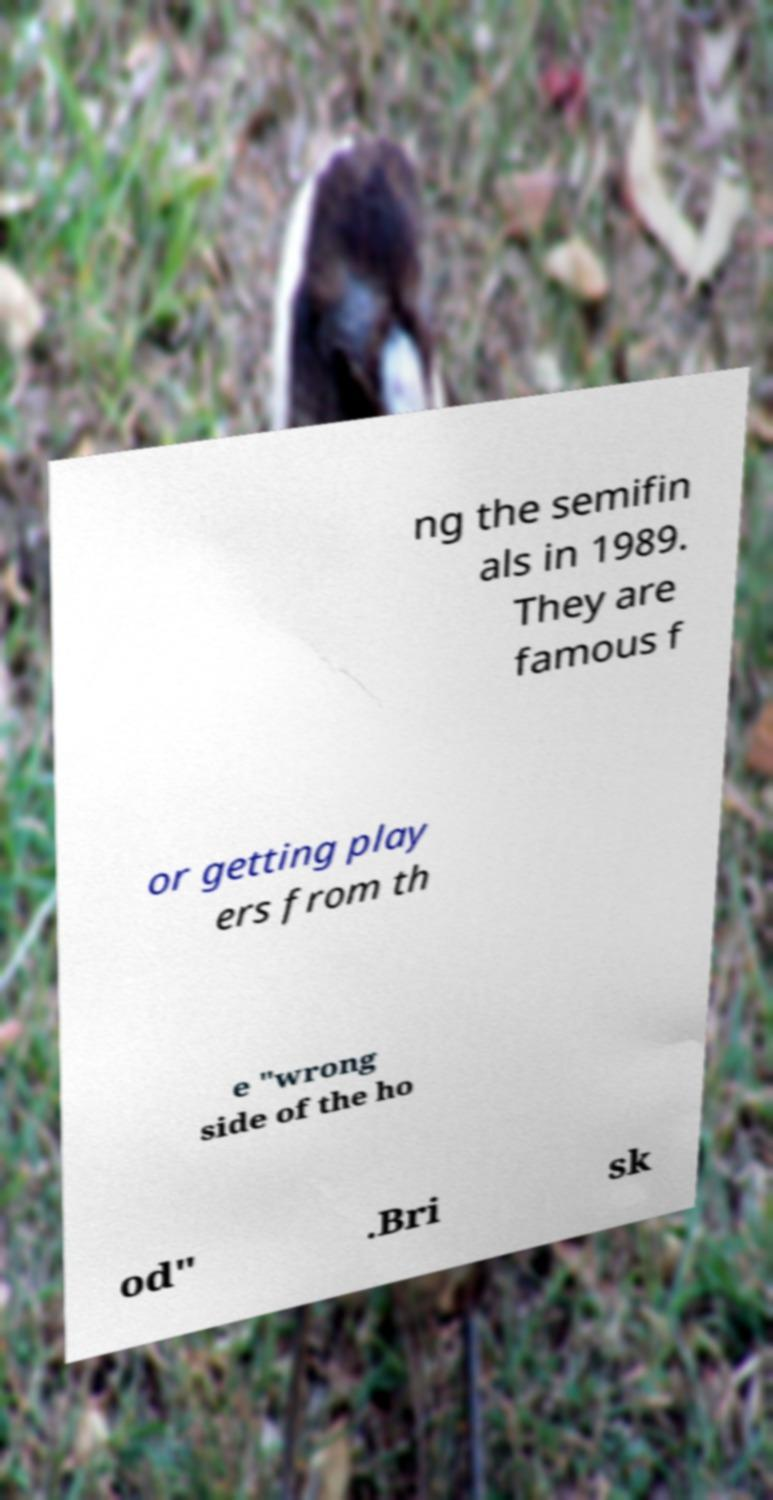For documentation purposes, I need the text within this image transcribed. Could you provide that? ng the semifin als in 1989. They are famous f or getting play ers from th e "wrong side of the ho od" .Bri sk 